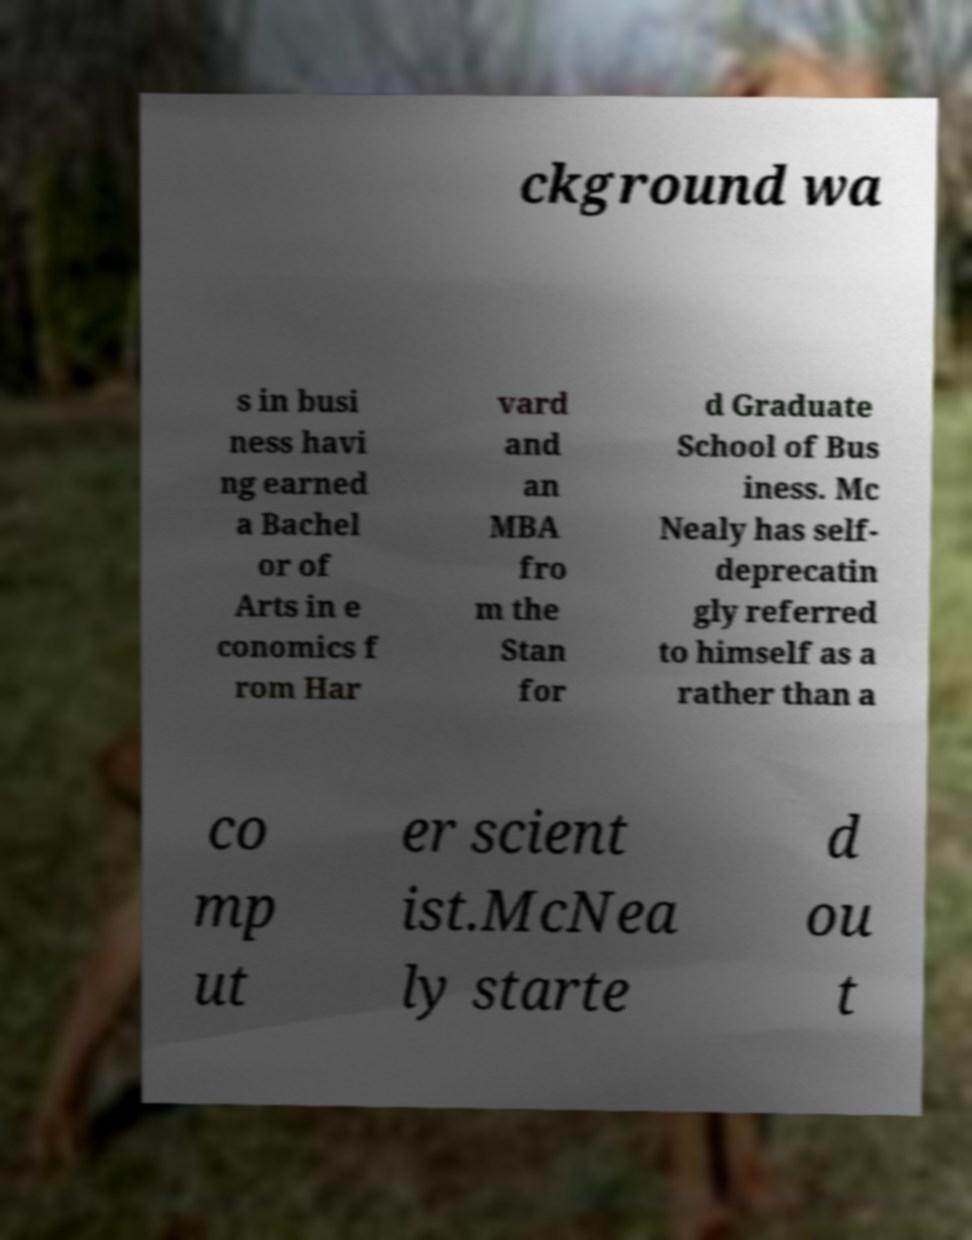Please identify and transcribe the text found in this image. ckground wa s in busi ness havi ng earned a Bachel or of Arts in e conomics f rom Har vard and an MBA fro m the Stan for d Graduate School of Bus iness. Mc Nealy has self- deprecatin gly referred to himself as a rather than a co mp ut er scient ist.McNea ly starte d ou t 